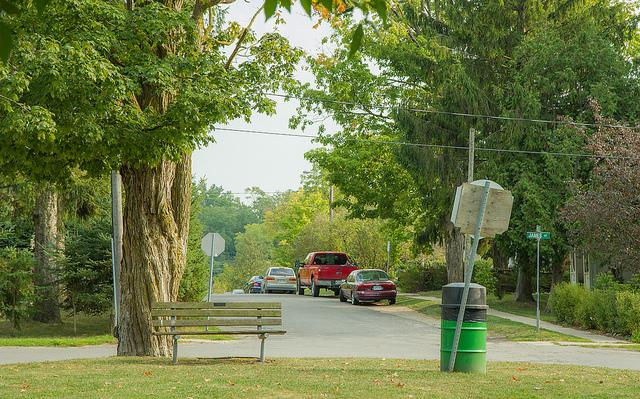What does the plaque on the back of this bench say? Please explain your reasoning. dedication. The plaque on the rear of the bench is a dedication. 